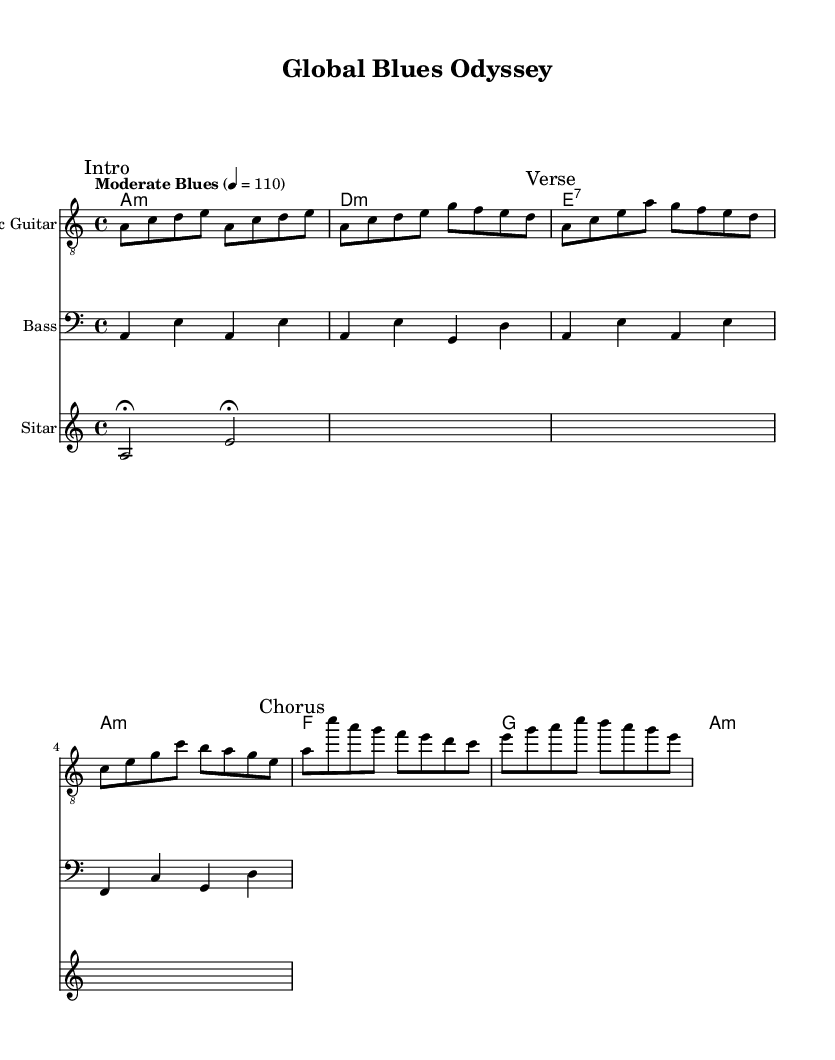What is the key signature of this music? The key signature is A minor, which has no sharps or flats, as indicated by the key signature at the beginning of the score.
Answer: A minor What is the time signature of this music? The time signature is 4/4, found at the beginning of the score, indicating four beats per measure.
Answer: 4/4 What is the tempo marking for this piece? The tempo marking is "Moderate Blues," which indicates a moderate pace for the performance. The tempo is measured at 110 beats per minute.
Answer: Moderate Blues How many measures are in the electric guitar part? The electric guitar part consists of eight measures, as counted by the sequences of vertical lines dividing the staff.
Answer: Eight measures What instrument has a fermata in its part? The Sitar has a fermata noted by the symbol over the two beats, indicating that those notes should be held longer than their usual duration.
Answer: Sitar Which chord appears first in the chord progression? The first chord in the chord progression is A minor, as indicated by the first chord notated in the chord line.
Answer: A minor What is unique about the use of instruments in this piece? The piece incorporates the electric guitar, bass, and sitar, blending traditional blues elements with cultural sound influences to achieve a worldly sound.
Answer: Diverse instruments 